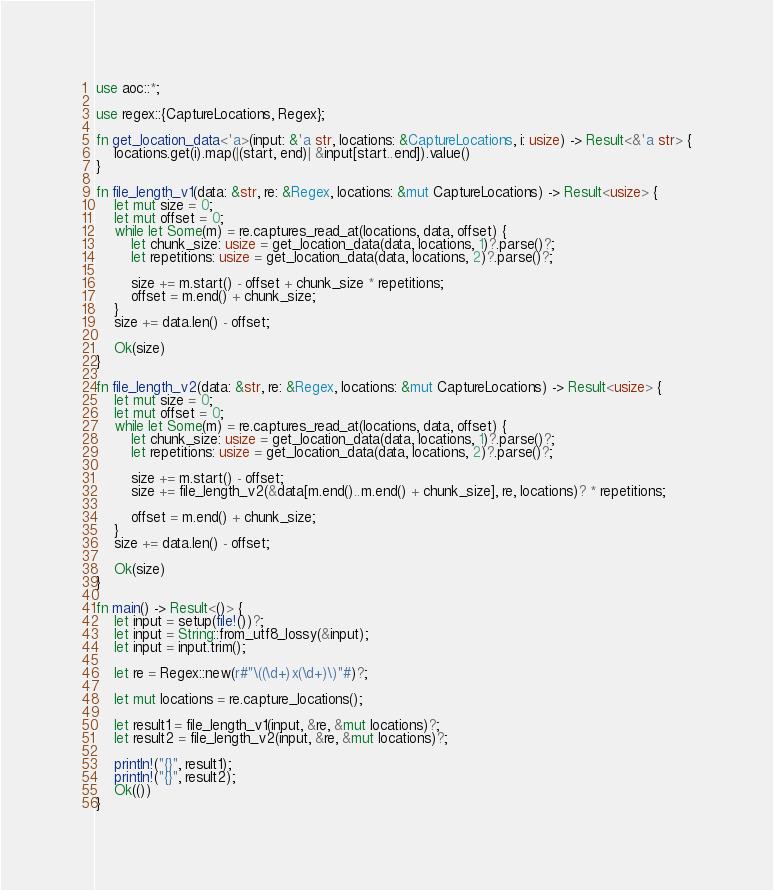Convert code to text. <code><loc_0><loc_0><loc_500><loc_500><_Rust_>use aoc::*;

use regex::{CaptureLocations, Regex};

fn get_location_data<'a>(input: &'a str, locations: &CaptureLocations, i: usize) -> Result<&'a str> {
    locations.get(i).map(|(start, end)| &input[start..end]).value()
}

fn file_length_v1(data: &str, re: &Regex, locations: &mut CaptureLocations) -> Result<usize> {
    let mut size = 0;
    let mut offset = 0;
    while let Some(m) = re.captures_read_at(locations, data, offset) {
        let chunk_size: usize = get_location_data(data, locations, 1)?.parse()?;
        let repetitions: usize = get_location_data(data, locations, 2)?.parse()?;

        size += m.start() - offset + chunk_size * repetitions;
        offset = m.end() + chunk_size;
    }
    size += data.len() - offset;

    Ok(size)
}

fn file_length_v2(data: &str, re: &Regex, locations: &mut CaptureLocations) -> Result<usize> {
    let mut size = 0;
    let mut offset = 0;
    while let Some(m) = re.captures_read_at(locations, data, offset) {
        let chunk_size: usize = get_location_data(data, locations, 1)?.parse()?;
        let repetitions: usize = get_location_data(data, locations, 2)?.parse()?;

        size += m.start() - offset;
        size += file_length_v2(&data[m.end()..m.end() + chunk_size], re, locations)? * repetitions;

        offset = m.end() + chunk_size;
    }
    size += data.len() - offset;

    Ok(size)
}

fn main() -> Result<()> {
    let input = setup(file!())?;
    let input = String::from_utf8_lossy(&input);
    let input = input.trim();

    let re = Regex::new(r#"\((\d+)x(\d+)\)"#)?;

    let mut locations = re.capture_locations();

    let result1 = file_length_v1(input, &re, &mut locations)?;
    let result2 = file_length_v2(input, &re, &mut locations)?;

    println!("{}", result1);
    println!("{}", result2);
    Ok(())
}
</code> 